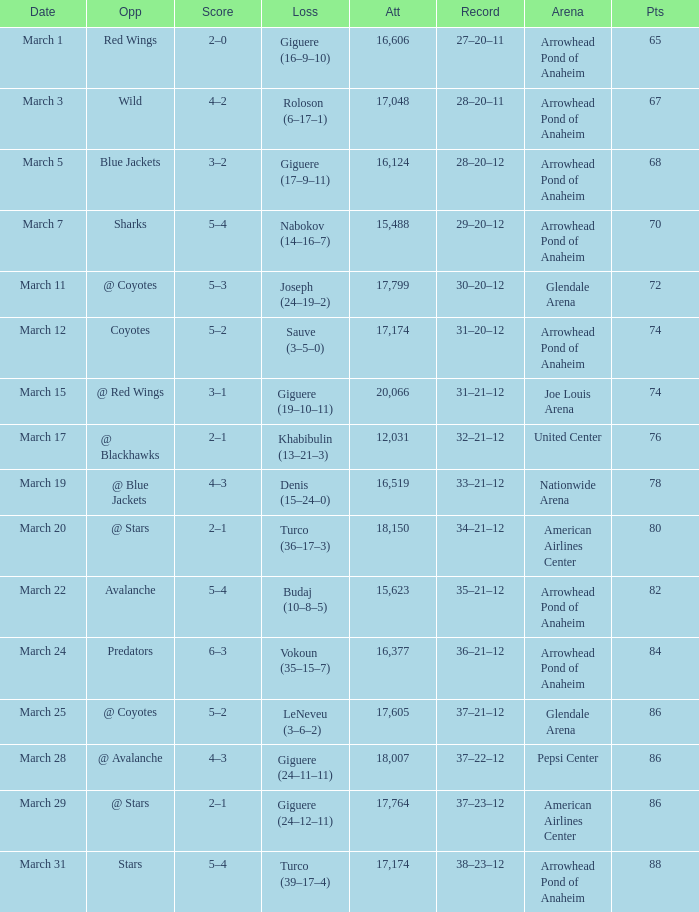What is the Score of the game on March 19? 4–3. 